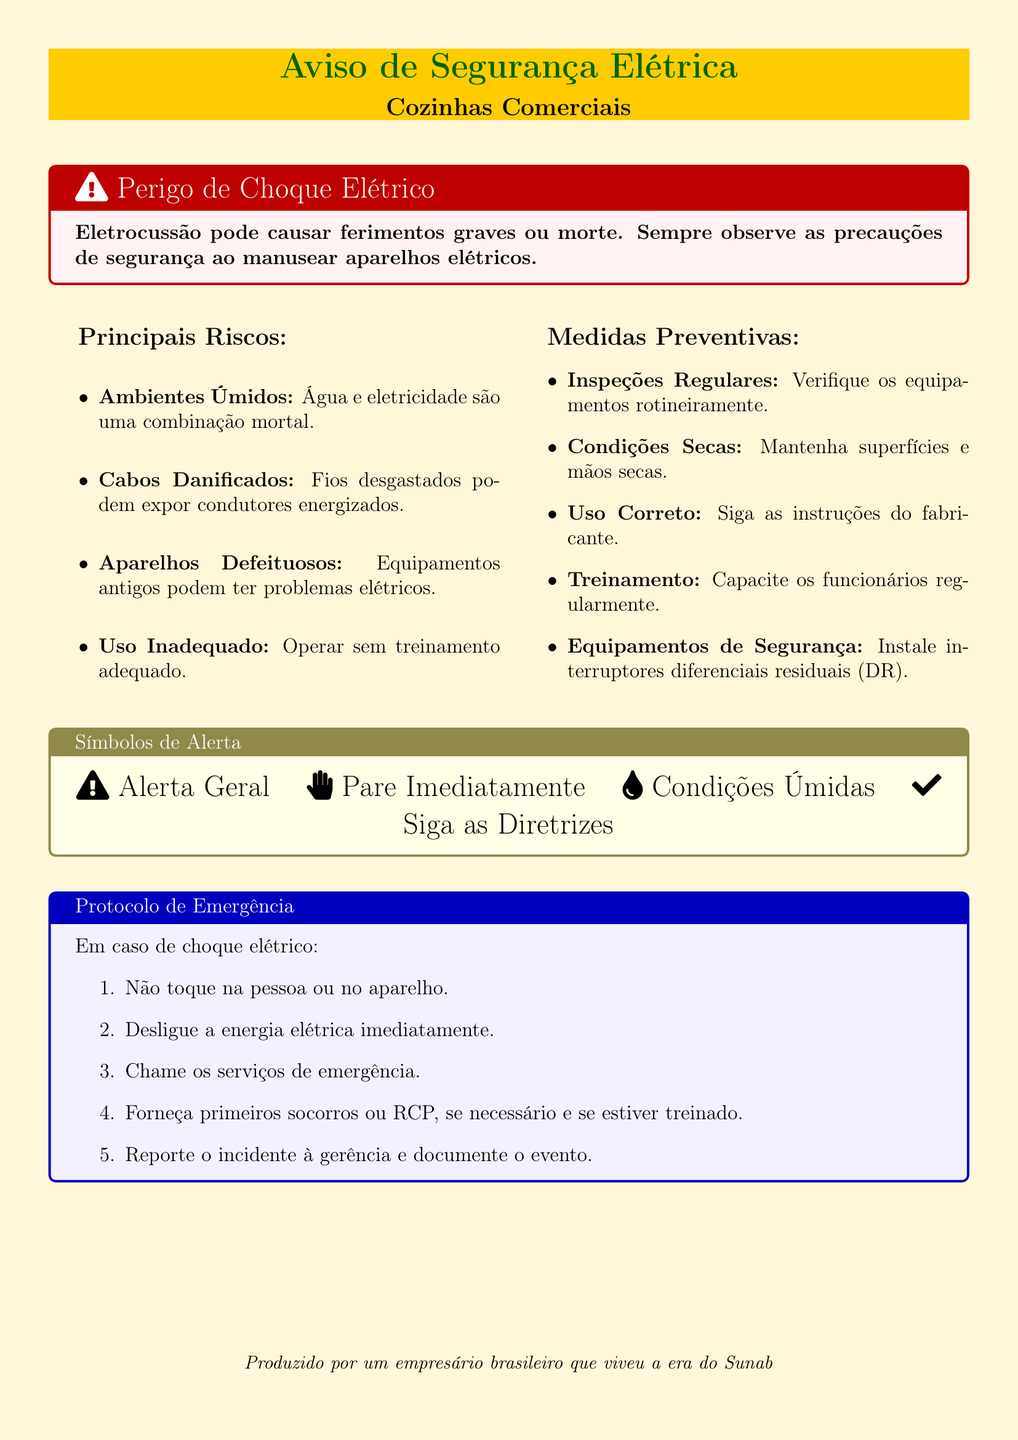What is the main hazard mentioned in the warning? The main hazard mentioned is electric shock, which can cause severe injuries or death.
Answer: Electric shock What color is used for the title in the warning label? The title is presented in dark green color.
Answer: Dark green What should be done immediately in case of electric shock? The document states to "desligue a energia elétrica imediatamente" (turn off the electricity immediately).
Answer: Desligue a energia elétrica imediatamente What is one example of a preventive measure listed? Among the measures, "Inspeções Regulares" (Regular Inspections) is provided as an example.
Answer: Inspeções Regulares What are the conditions that should be maintained in the kitchen? The document advises maintaining conditions that are "Secas" (Dry).
Answer: Secas How many emergency protocol steps are provided? There are five steps listed in the emergency protocol.
Answer: 5 What warning symbol indicates a general alert? The document uses the symbol from Font Awesome: "Exclamation Triangle" for general alerts.
Answer: Exclamation Triangle What is advised regarding the use of old equipment? The document indicates that "Aparelhos Defeituosos" (Defective appliances) can have electrical problems, which should be avoided.
Answer: Aparelhos Defeituosos 